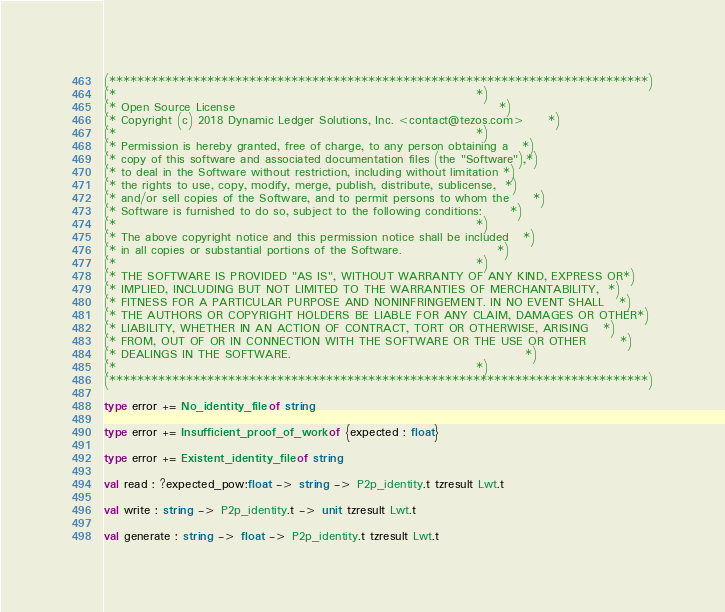Convert code to text. <code><loc_0><loc_0><loc_500><loc_500><_OCaml_>(*****************************************************************************)
(*                                                                           *)
(* Open Source License                                                       *)
(* Copyright (c) 2018 Dynamic Ledger Solutions, Inc. <contact@tezos.com>     *)
(*                                                                           *)
(* Permission is hereby granted, free of charge, to any person obtaining a   *)
(* copy of this software and associated documentation files (the "Software"),*)
(* to deal in the Software without restriction, including without limitation *)
(* the rights to use, copy, modify, merge, publish, distribute, sublicense,  *)
(* and/or sell copies of the Software, and to permit persons to whom the     *)
(* Software is furnished to do so, subject to the following conditions:      *)
(*                                                                           *)
(* The above copyright notice and this permission notice shall be included   *)
(* in all copies or substantial portions of the Software.                    *)
(*                                                                           *)
(* THE SOFTWARE IS PROVIDED "AS IS", WITHOUT WARRANTY OF ANY KIND, EXPRESS OR*)
(* IMPLIED, INCLUDING BUT NOT LIMITED TO THE WARRANTIES OF MERCHANTABILITY,  *)
(* FITNESS FOR A PARTICULAR PURPOSE AND NONINFRINGEMENT. IN NO EVENT SHALL   *)
(* THE AUTHORS OR COPYRIGHT HOLDERS BE LIABLE FOR ANY CLAIM, DAMAGES OR OTHER*)
(* LIABILITY, WHETHER IN AN ACTION OF CONTRACT, TORT OR OTHERWISE, ARISING   *)
(* FROM, OUT OF OR IN CONNECTION WITH THE SOFTWARE OR THE USE OR OTHER       *)
(* DEALINGS IN THE SOFTWARE.                                                 *)
(*                                                                           *)
(*****************************************************************************)

type error += No_identity_file of string

type error += Insufficient_proof_of_work of {expected : float}

type error += Existent_identity_file of string

val read : ?expected_pow:float -> string -> P2p_identity.t tzresult Lwt.t

val write : string -> P2p_identity.t -> unit tzresult Lwt.t

val generate : string -> float -> P2p_identity.t tzresult Lwt.t
</code> 